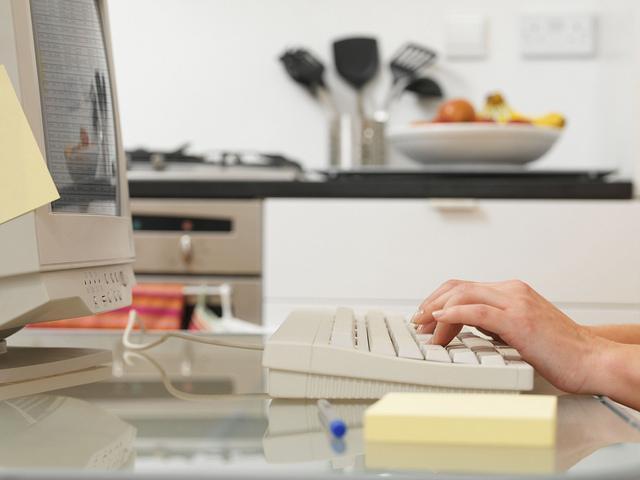How many spatulas are there?
Give a very brief answer. 2. How many of the chairs are blue?
Give a very brief answer. 0. 